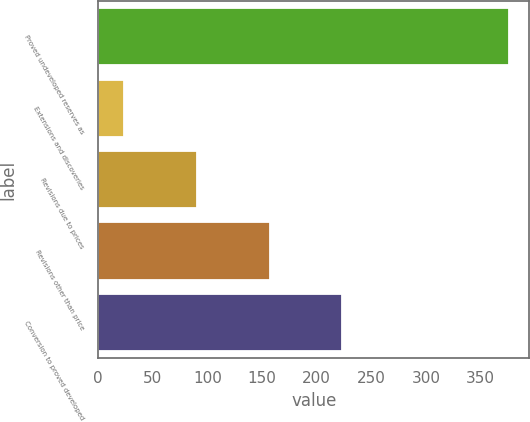Convert chart to OTSL. <chart><loc_0><loc_0><loc_500><loc_500><bar_chart><fcel>Proved undeveloped reserves as<fcel>Extensions and discoveries<fcel>Revisions due to prices<fcel>Revisions other than price<fcel>Conversion to proved developed<nl><fcel>376<fcel>24<fcel>90.5<fcel>157<fcel>223.5<nl></chart> 